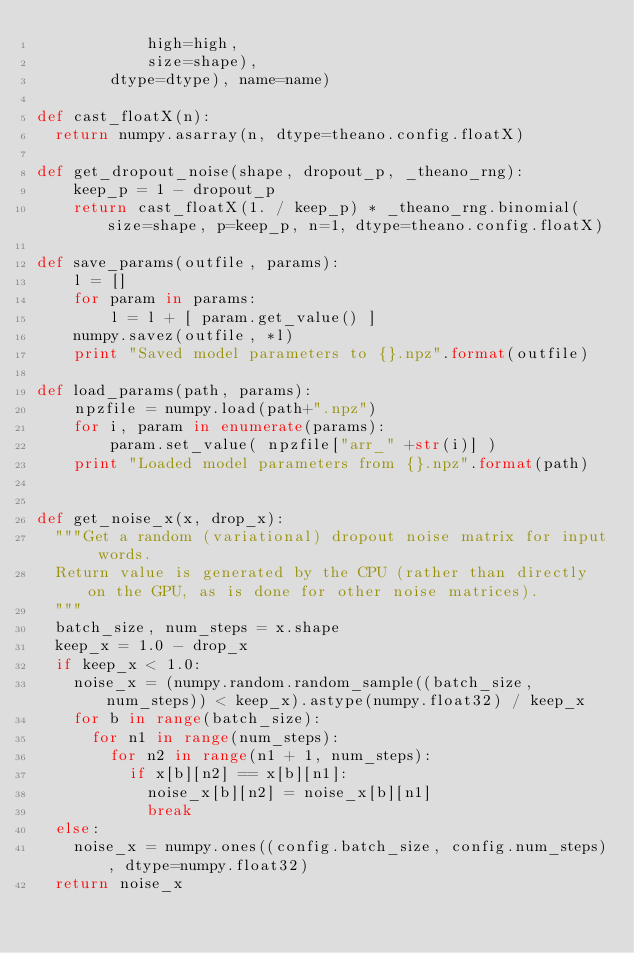<code> <loc_0><loc_0><loc_500><loc_500><_Python_>            high=high,
            size=shape),
        dtype=dtype), name=name)

def cast_floatX(n):
  return numpy.asarray(n, dtype=theano.config.floatX)

def get_dropout_noise(shape, dropout_p, _theano_rng):
    keep_p = 1 - dropout_p
    return cast_floatX(1. / keep_p) * _theano_rng.binomial(size=shape, p=keep_p, n=1, dtype=theano.config.floatX)

def save_params(outfile, params):
    l = []
    for param in params:
        l = l + [ param.get_value() ]
    numpy.savez(outfile, *l)
    print "Saved model parameters to {}.npz".format(outfile)

def load_params(path, params):
    npzfile = numpy.load(path+".npz")
    for i, param in enumerate(params):
        param.set_value( npzfile["arr_" +str(i)] )
    print "Loaded model parameters from {}.npz".format(path)


def get_noise_x(x, drop_x):
  """Get a random (variational) dropout noise matrix for input words.
  Return value is generated by the CPU (rather than directly on the GPU, as is done for other noise matrices).
  """
  batch_size, num_steps = x.shape
  keep_x = 1.0 - drop_x
  if keep_x < 1.0:
    noise_x = (numpy.random.random_sample((batch_size, num_steps)) < keep_x).astype(numpy.float32) / keep_x
    for b in range(batch_size):
      for n1 in range(num_steps):
        for n2 in range(n1 + 1, num_steps):
          if x[b][n2] == x[b][n1]:
            noise_x[b][n2] = noise_x[b][n1]
            break
  else:
    noise_x = numpy.ones((config.batch_size, config.num_steps), dtype=numpy.float32)
  return noise_x
</code> 